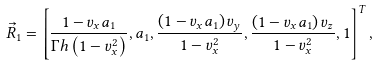Convert formula to latex. <formula><loc_0><loc_0><loc_500><loc_500>\vec { R } _ { 1 } = \left [ \frac { 1 - v _ { x } a _ { 1 } } { \Gamma h \left ( 1 - v _ { x } ^ { 2 } \right ) } , a _ { 1 } , \frac { \left ( 1 - v _ { x } a _ { 1 } \right ) v _ { y } } { 1 - v _ { x } ^ { 2 } } , \frac { \left ( 1 - v _ { x } a _ { 1 } \right ) v _ { z } } { 1 - v _ { x } ^ { 2 } } , 1 \right ] ^ { T } ,</formula> 